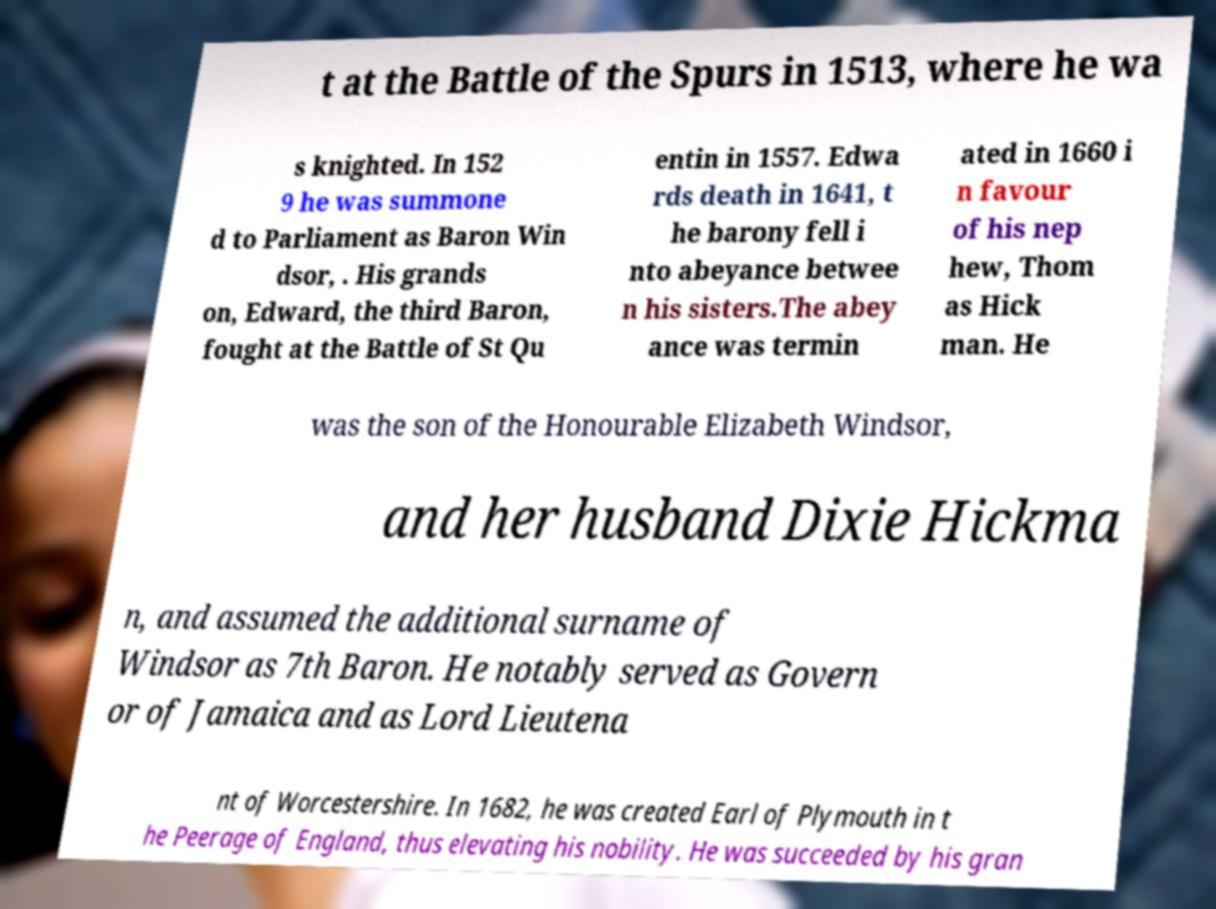Can you accurately transcribe the text from the provided image for me? t at the Battle of the Spurs in 1513, where he wa s knighted. In 152 9 he was summone d to Parliament as Baron Win dsor, . His grands on, Edward, the third Baron, fought at the Battle of St Qu entin in 1557. Edwa rds death in 1641, t he barony fell i nto abeyance betwee n his sisters.The abey ance was termin ated in 1660 i n favour of his nep hew, Thom as Hick man. He was the son of the Honourable Elizabeth Windsor, and her husband Dixie Hickma n, and assumed the additional surname of Windsor as 7th Baron. He notably served as Govern or of Jamaica and as Lord Lieutena nt of Worcestershire. In 1682, he was created Earl of Plymouth in t he Peerage of England, thus elevating his nobility. He was succeeded by his gran 